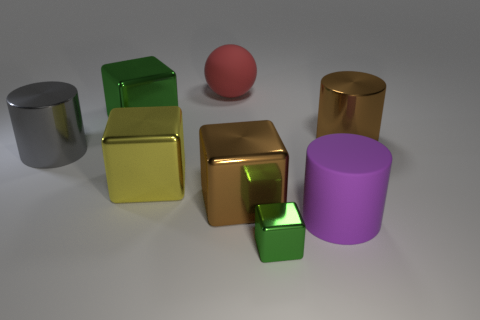Add 1 brown cylinders. How many objects exist? 9 Subtract all cylinders. How many objects are left? 5 Subtract 0 yellow cylinders. How many objects are left? 8 Subtract all green shiny cubes. Subtract all large green blocks. How many objects are left? 5 Add 8 purple matte things. How many purple matte things are left? 9 Add 2 large gray cylinders. How many large gray cylinders exist? 3 